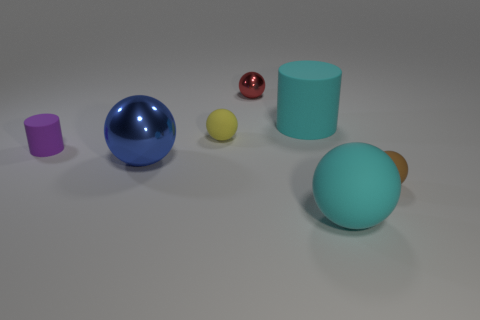Do the large metallic ball and the tiny metallic object have the same color?
Keep it short and to the point. No. Is there any other thing that is the same shape as the small brown thing?
Make the answer very short. Yes. Are there any metal things of the same color as the big metal sphere?
Your answer should be very brief. No. Is the big object behind the large blue ball made of the same material as the big cyan object that is in front of the tiny purple matte cylinder?
Give a very brief answer. Yes. The large matte ball is what color?
Your answer should be compact. Cyan. What size is the rubber ball that is in front of the small matte sphere to the right of the small ball behind the large matte cylinder?
Offer a terse response. Large. How many other objects are there of the same size as the purple matte cylinder?
Provide a short and direct response. 3. What number of tiny brown objects have the same material as the cyan cylinder?
Keep it short and to the point. 1. There is a tiny thing in front of the tiny purple cylinder; what is its shape?
Provide a succinct answer. Sphere. Does the tiny yellow thing have the same material as the small object that is in front of the small purple matte cylinder?
Your response must be concise. Yes. 